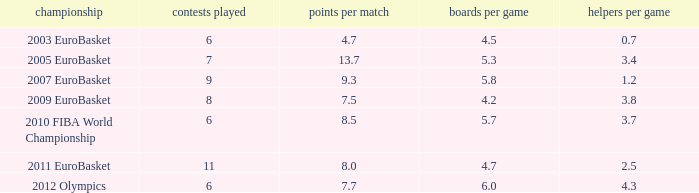How many assists per game have 4.2 rebounds per game? 3.8. 